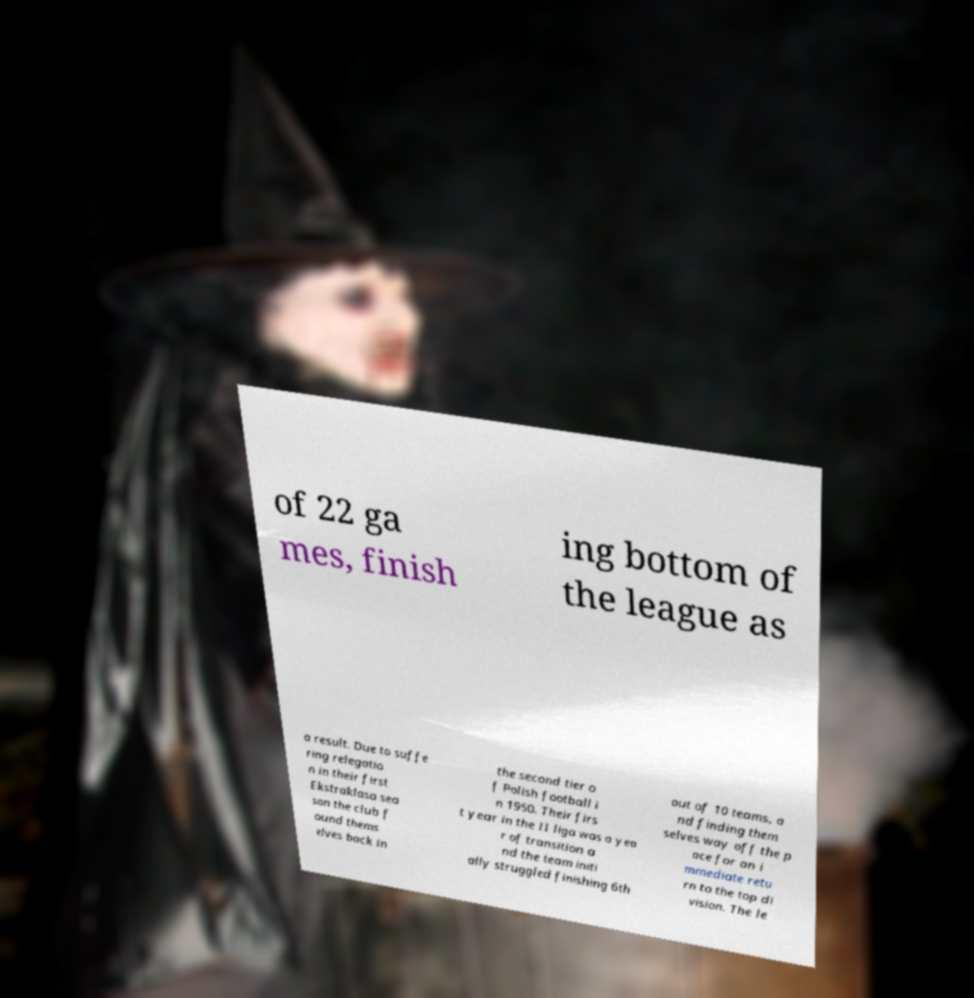I need the written content from this picture converted into text. Can you do that? of 22 ga mes, finish ing bottom of the league as a result. Due to suffe ring relegatio n in their first Ekstraklasa sea son the club f ound thems elves back in the second tier o f Polish football i n 1950. Their firs t year in the II liga was a yea r of transition a nd the team initi ally struggled finishing 6th out of 10 teams, a nd finding them selves way off the p ace for an i mmediate retu rn to the top di vision. The le 